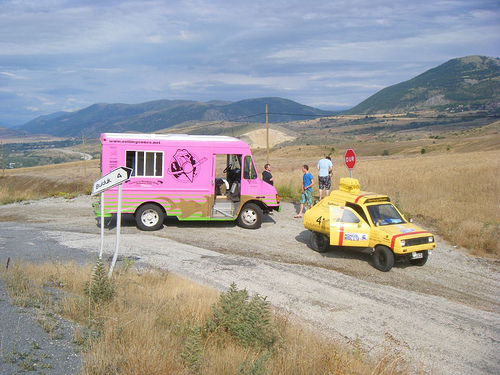Please transcribe the text information in this image. 4 